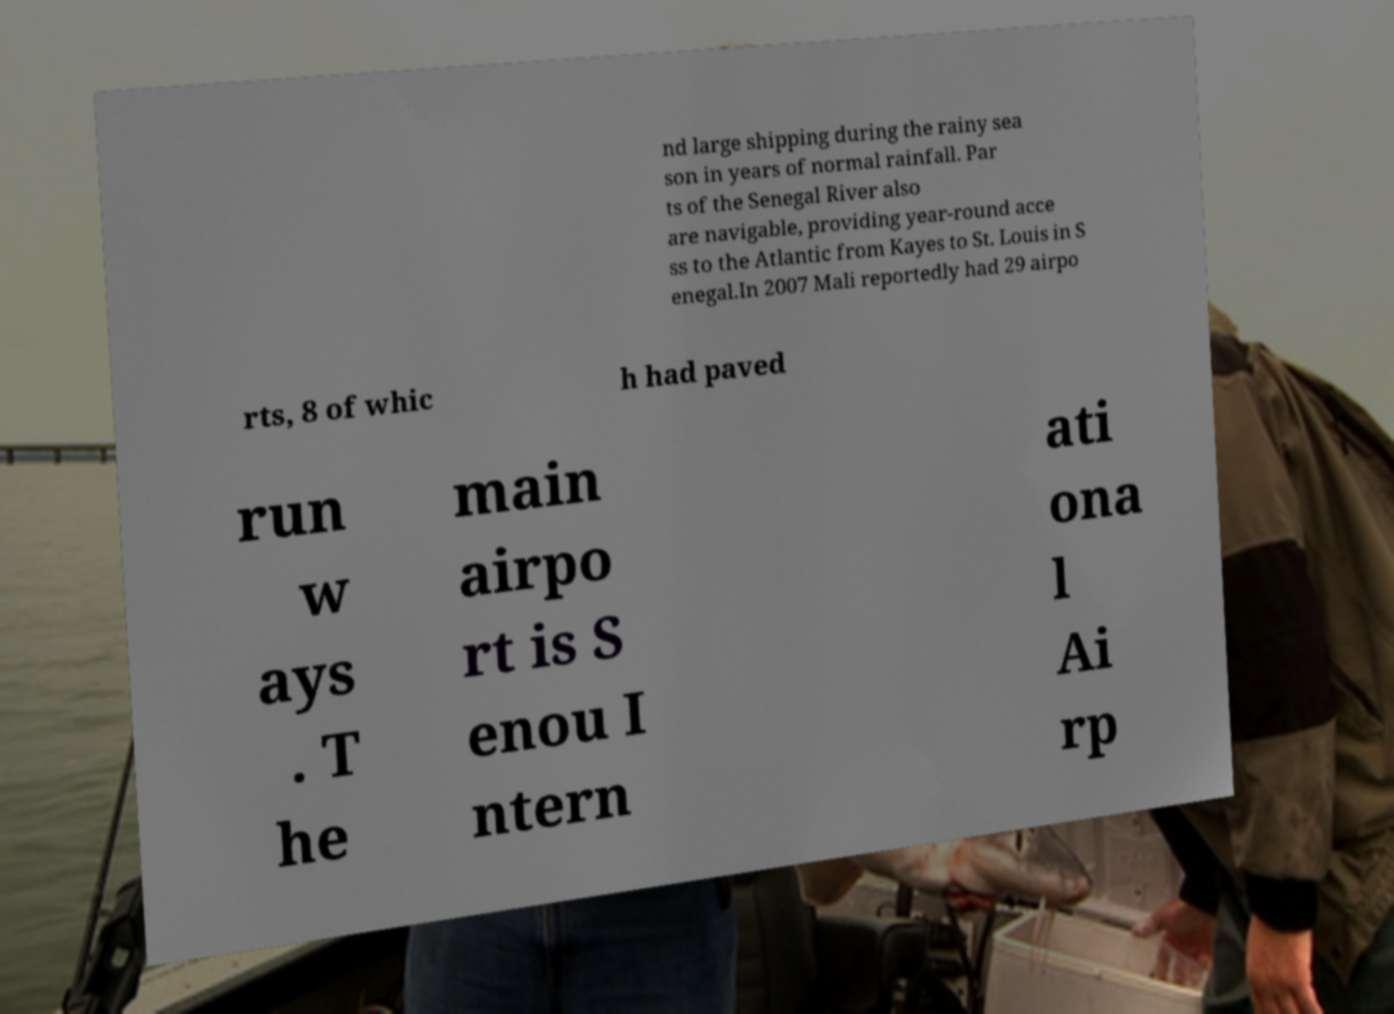Can you accurately transcribe the text from the provided image for me? nd large shipping during the rainy sea son in years of normal rainfall. Par ts of the Senegal River also are navigable, providing year-round acce ss to the Atlantic from Kayes to St. Louis in S enegal.In 2007 Mali reportedly had 29 airpo rts, 8 of whic h had paved run w ays . T he main airpo rt is S enou I ntern ati ona l Ai rp 